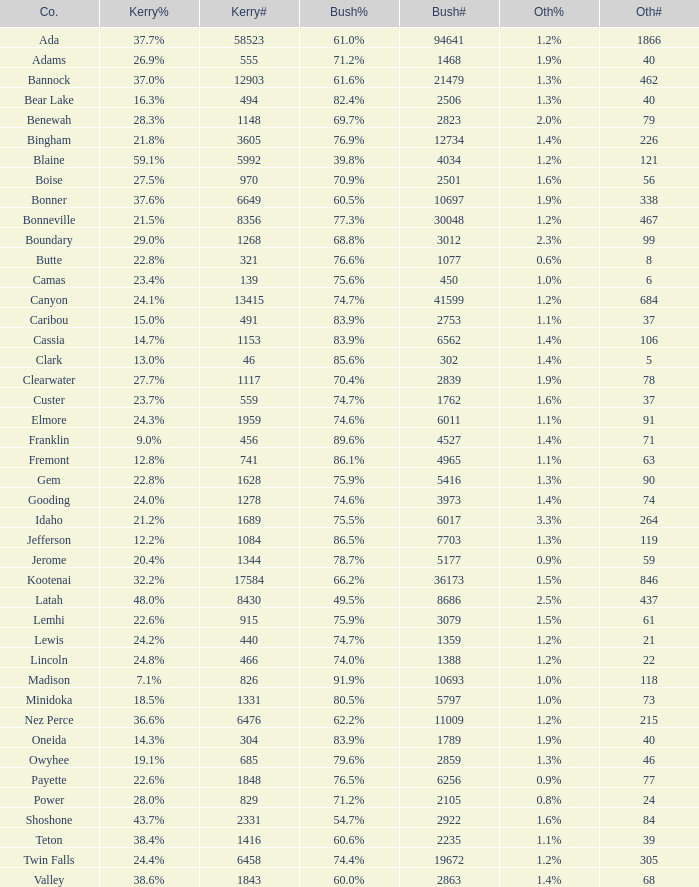What's percentage voted for Busg in the county where Kerry got 37.6%? 60.5%. 